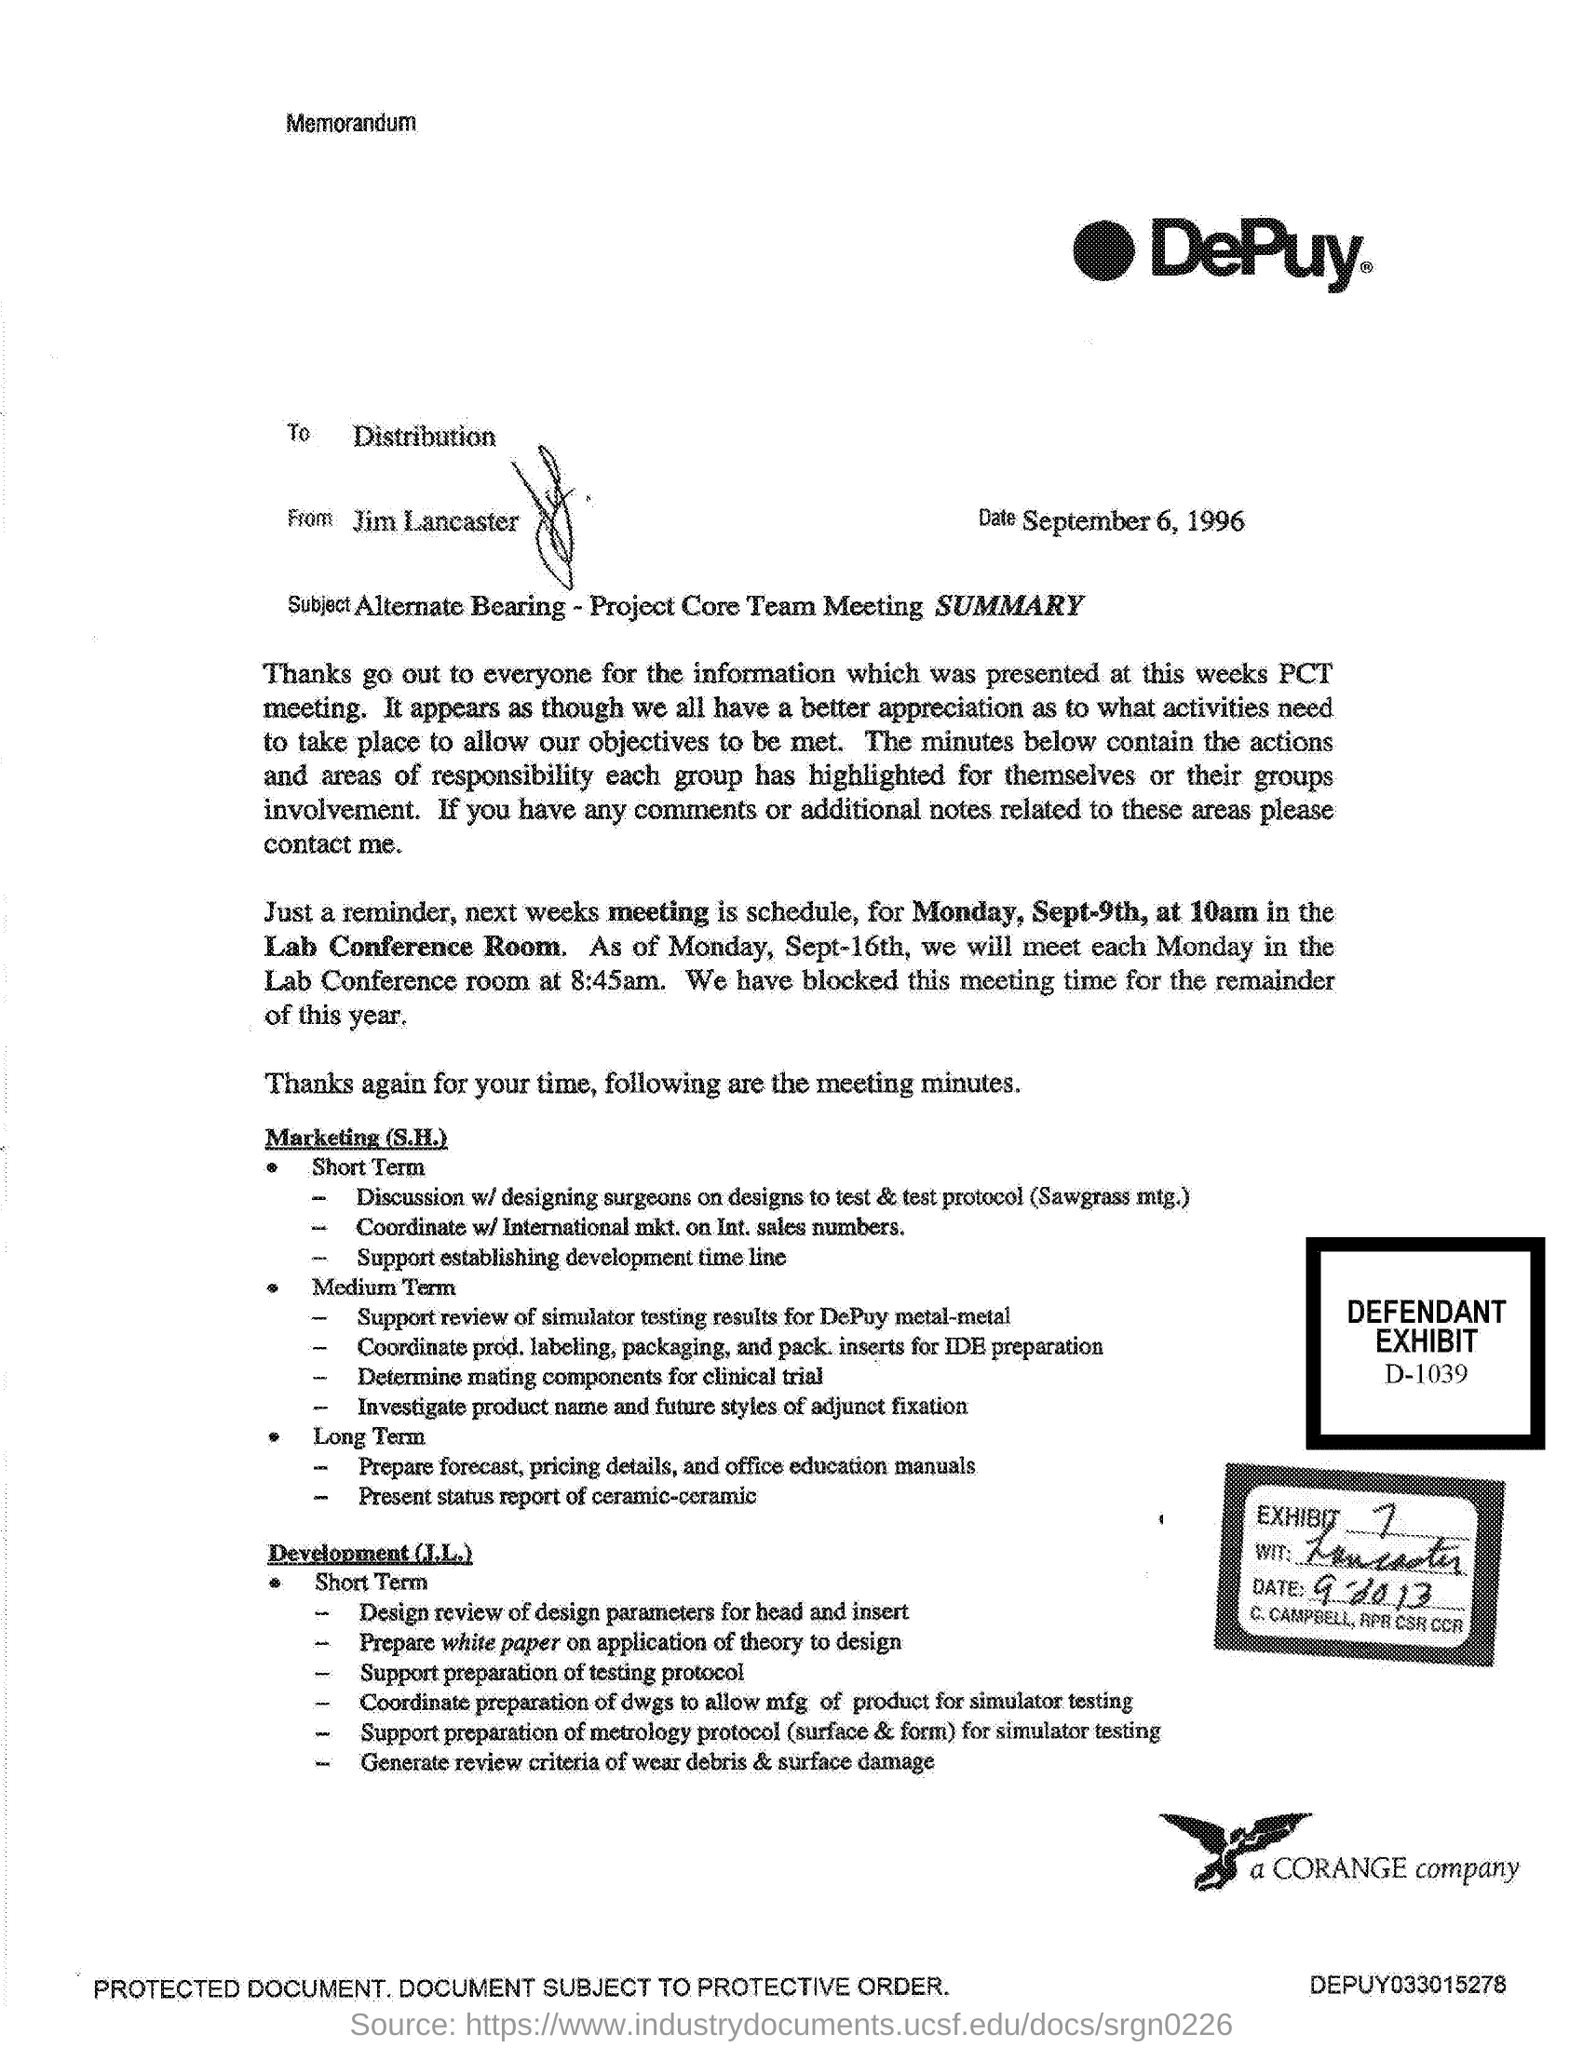Outline some significant characteristics in this image. D-1039 is the defendant's exhibit number given in the document. This is a memorandum, a type of communication. The sender of this memorandum is Jim Lancaster. The memorandum is addressed to the distribution of the specified individuals. The memorandum provided is from DePuy. 